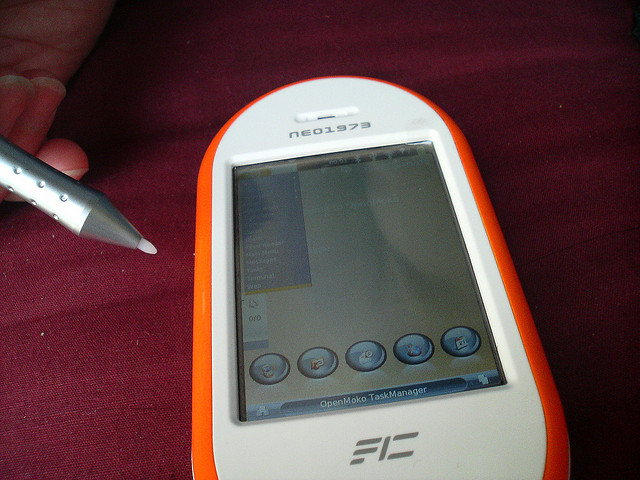Please transcribe the text in this image. Openmoko 